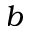<formula> <loc_0><loc_0><loc_500><loc_500>b</formula> 